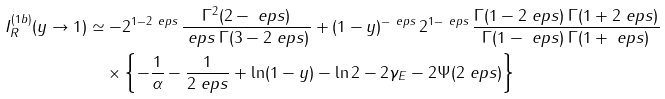<formula> <loc_0><loc_0><loc_500><loc_500>I _ { R } ^ { ( 1 b ) } ( y \to 1 ) & \simeq - 2 ^ { 1 - 2 \ e p s } \, \frac { \Gamma ^ { 2 } ( 2 - \ e p s ) } { \ e p s \, \Gamma ( 3 - 2 \ e p s ) } + ( 1 - y ) ^ { - \ e p s } \, 2 ^ { 1 - \ e p s } \, \frac { \Gamma ( 1 - 2 \ e p s ) \, \Gamma ( 1 + 2 \ e p s ) } { \Gamma ( 1 - \ e p s ) \, \Gamma ( 1 + \ e p s ) } \\ & \quad \times \left \{ - \frac { 1 } { \alpha } - \frac { 1 } { 2 \ e p s } + \ln ( 1 - y ) - \ln 2 - 2 \gamma _ { E } - 2 \Psi ( 2 \ e p s ) \right \}</formula> 